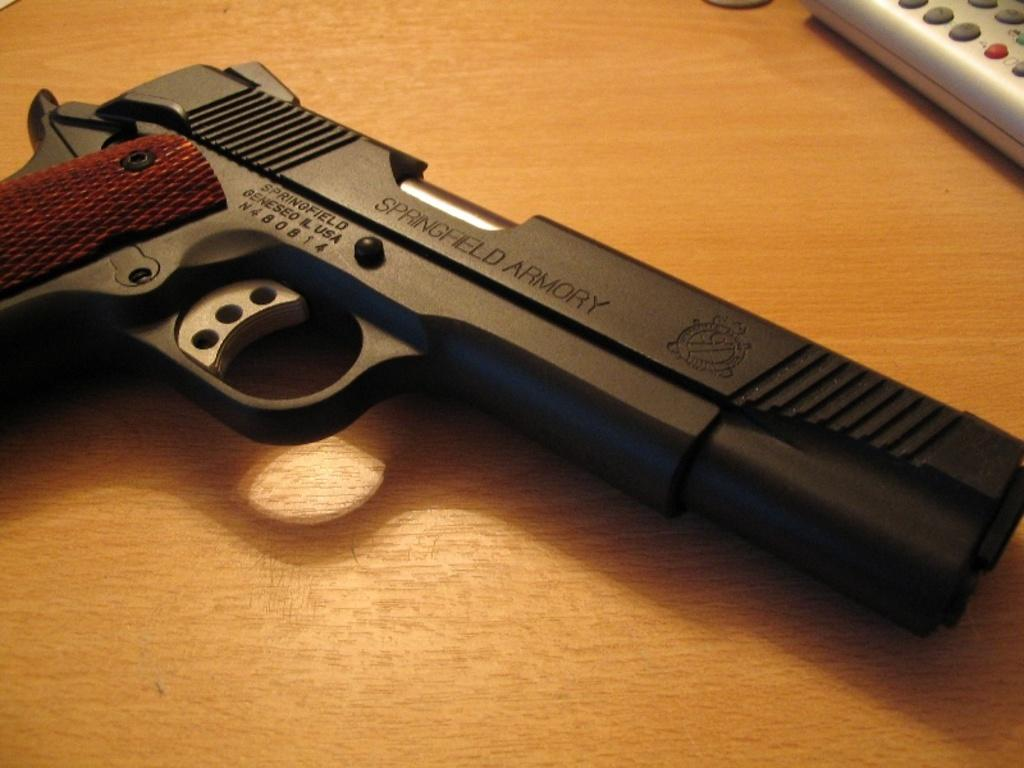What type of furniture is present in the image? There is a table in the image. What object can be seen on the table? There is a black color gun on the table. What other item is on the table besides the gun? There is a remote on the table. What type of lettuce is present on the table in the image? There is no lettuce present on the table in the image. Is the string visible in the image? There is no string visible in the image. 